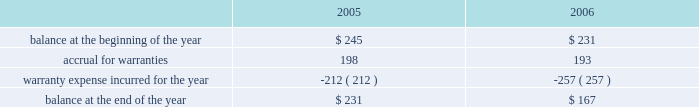Abiomed , inc .
And subsidiaries notes to consolidated financial statements 2014 ( continued ) evidence of an arrangement exists , ( 2 ) delivery has occurred or services have been rendered , ( 3 ) the seller 2019s price to the buyer is fixed or determinable , and ( 4 ) collectibility is reasonably assured .
Further , sab 104 requires that both title and the risks and rewards of ownership be transferred to the buyer before revenue can be recognized .
In addition to sab 104 , we follow the guidance of eitf 00-21 , revenue arrangements with multiple deliverables .
We derive our revenues primarily from product sales , including maintenance service agreements .
The great majority of our product revenues are derived from shipments of our ab5000 and bvs 5000 product lines to fulfill customer orders for a specified number of consoles and/or blood pumps for a specified price .
We recognize revenues and record costs related to such sales upon product shipment .
Maintenance and service support contract revenues are recognized ratably over the term of the service contracts based upon the elapsed term of the service contract .
Government-sponsored research and development contracts and grants generally provide for payment on a cost-plus-fixed-fee basis .
Revenues from these contracts and grants are recognized as work is performed , provided the government has appropriated sufficient funds for the work .
Under contracts in which the company elects to spend significantly more on the development project during the term of the contract than the total contract amount , the company prospectively recognizes revenue on such contracts ratably over the term of the contract as it incurs related research and development costs , provided the government has appropriated sufficient funds for the work .
( d ) translation of foreign currencies all assets and liabilities of the company 2019s non-u.s .
Subsidiaries are translated at year-end exchange rates , and revenues and expenses are translated at average exchange rates for the year in accordance with sfas no .
52 , foreign currency translation .
Resulting translation adjustments are reflected in the accumulated other comprehensive loss component of shareholders 2019 equity .
Currency transaction gains and losses are included in the accompanying statement of income and are not material for the three years presented .
( e ) warranties the company routinely accrues for estimated future warranty costs on its product sales at the time of sale .
Our products are subject to rigorous regulation and quality standards .
Warranty costs are included in cost of product revenues within the consolidated statements of operations .
The table summarizes the activities in the warranty reserve for the two fiscal years ended march 31 , 2006 ( in thousands ) .

What was the net change in warranty obligations from the end of 2004 to 2006? 
Computations: ((245 - 167) * 1000)
Answer: 78000.0. 